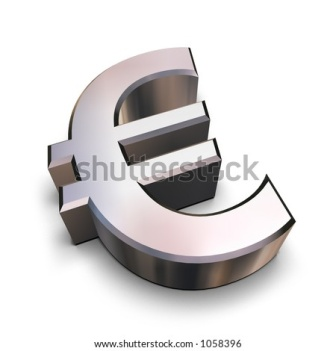What stories could this symbol tell if it could speak? If the Euro symbol could speak, it would tell tales of resilience and unity. It would recount the days of its inception, when European nations came together to forge a common economic future. It would share stories of financial crises weathered and economic rebounds, of diverse cultures unified under a single currency. Perhaps it would also speak of aspirations: a future where it continues to represent stability and cooperation amidst global challenges. What myths and legends could be crafted around this symbol? In a mythical world, the Euro symbol could be the emblem of a grand quest for a treasure that ensures eternal prosperity and peace. Guardians of ancient wisdom might have encrypted the symbol in sacred texts, guiding heroes through trials across the vast expanse of a united continent. Legends might speak of the symbol being forged in the heart of a celestial forge, imbued with powers by the gods of unity and fortune. Prophecies could foretell its role in bringing together disparate kingdoms, leading to an era of unmatched prosperity and harmony. 